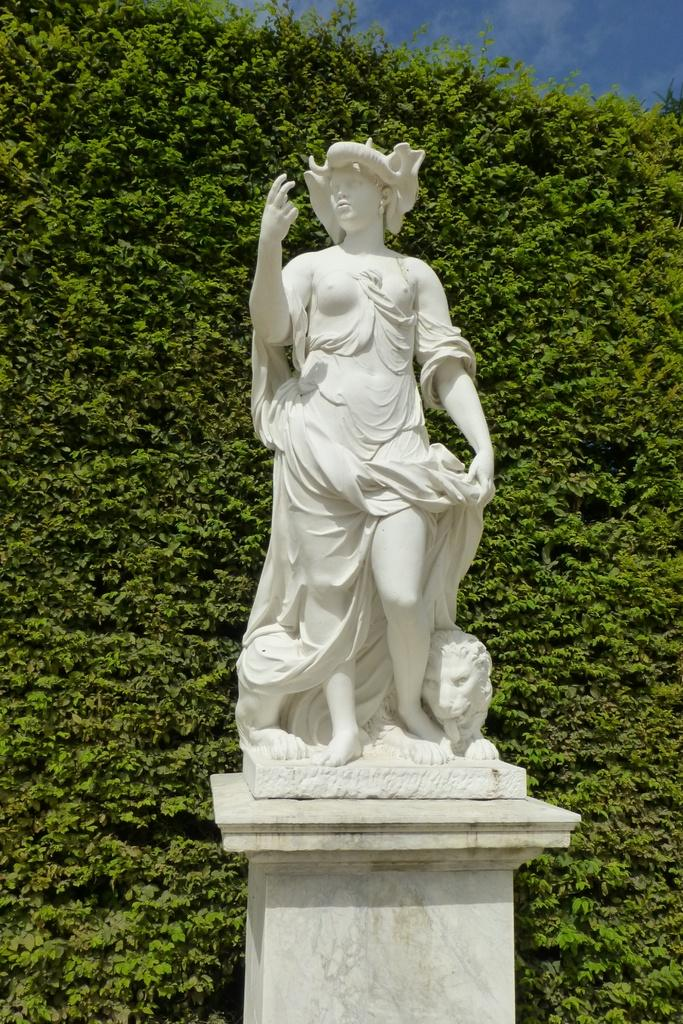What is the main subject on the pillar in the image? There is a sculpture on a pillar in the image. Who is present in the image besides the sculpture? There is a woman standing in the image, and an animal is beside her. What can be seen behind the sculpture in the image? There are hedges behind the sculpture in the image. What is visible at the top of the image? The sky is visible at the top of the image. What type of prose is being recited by the animal in the image? There is no indication in the image that the animal is reciting any prose. What type of trade is being conducted between the woman and the sculpture in the image? There is no trade being conducted between the woman and the sculpture in the image. 